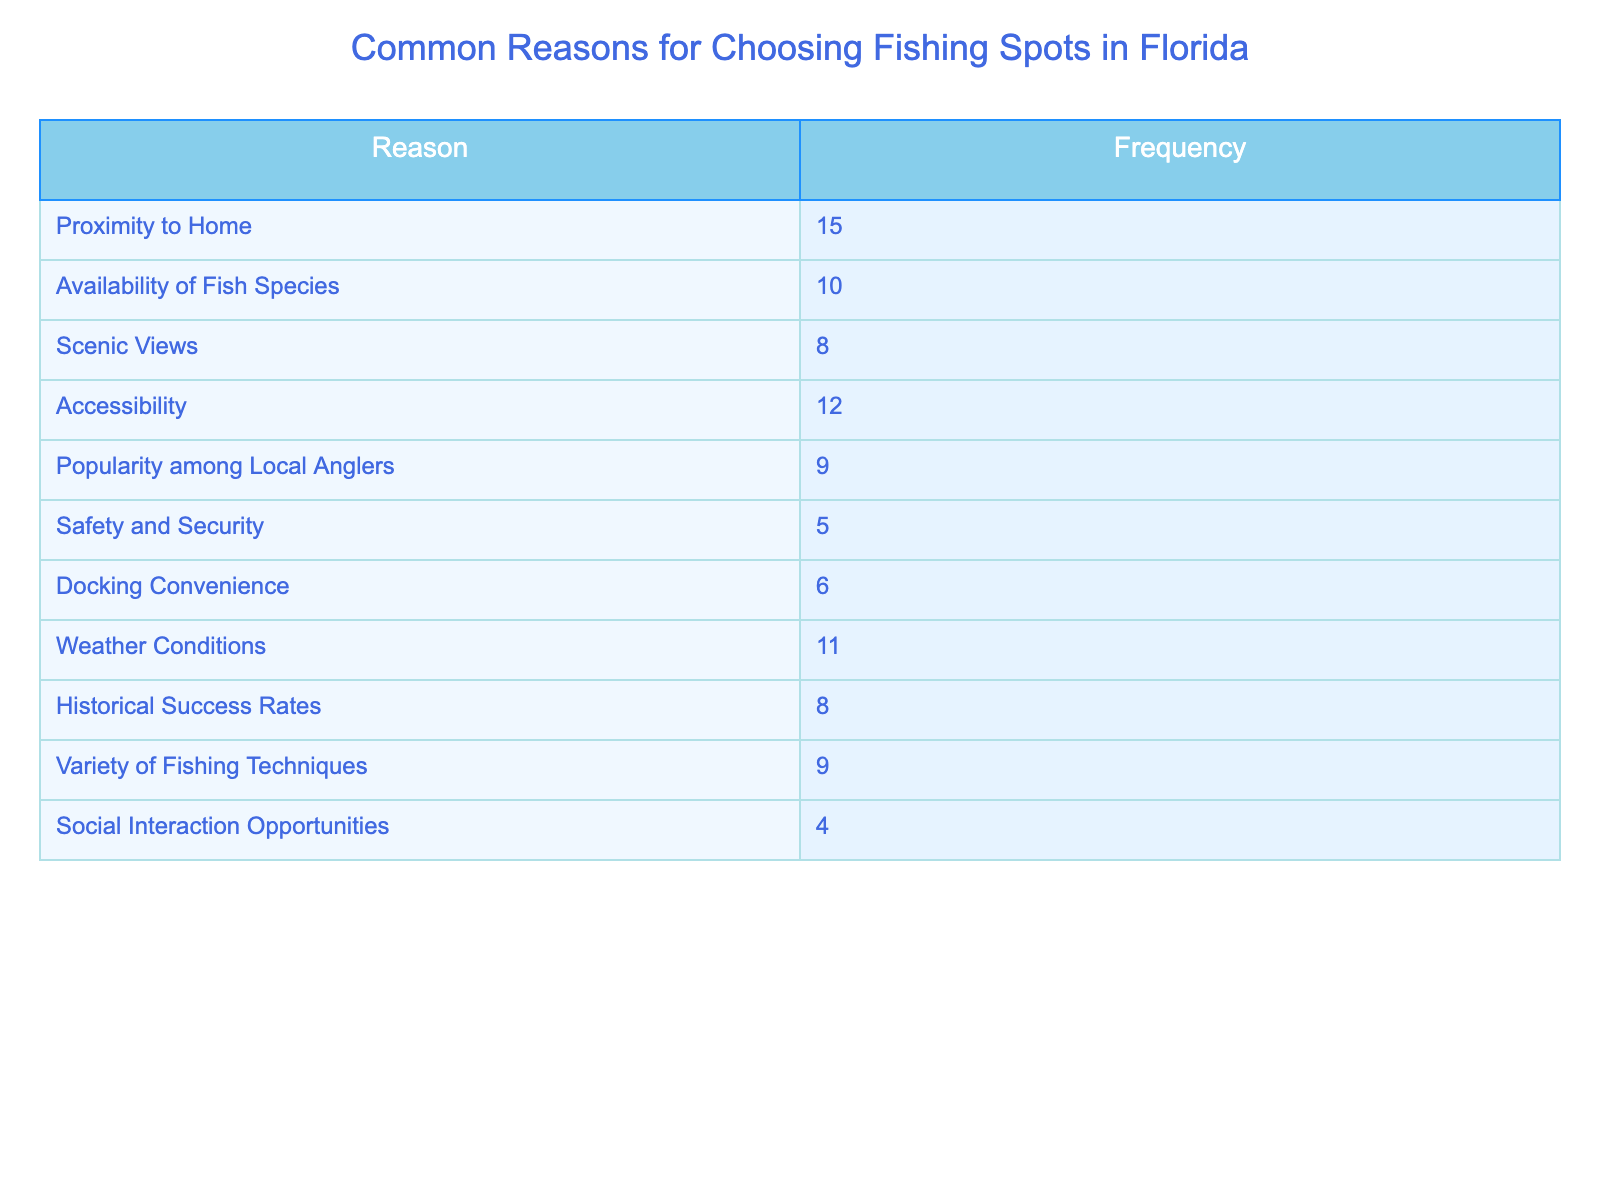What is the most common reason for choosing fishing spots in Florida? The table shows the frequency of each reason for choosing fishing spots in Florida. By looking at the frequency column, "Proximity to Home" has the highest frequency with a value of 15.
Answer: Proximity to Home How many reasons are listed in the table? The table includes a column for reasons and a column for frequency. Counting the reasons listed in the Reasons column, there are a total of 10 reasons.
Answer: 10 Which reason has the lowest frequency? By examining the frequency values in the table, "Social Interaction Opportunities" has the lowest frequency at 4.
Answer: Social Interaction Opportunities What is the average frequency of all reasons listed? To find the average, first sum all the frequencies: (15 + 10 + 8 + 12 + 9 + 5 + 6 + 11 + 8 + 9) = 89. Then, divide by the number of reasons (10): 89 / 10 = 8.9.
Answer: 8.9 Is "Weather Conditions" a more common reason than "Docking Convenience"? Comparing the frequencies from the table, "Weather Conditions" has a frequency of 11, while "Docking Convenience" has a frequency of 6. Since 11 is greater than 6, the answer is yes.
Answer: Yes How many reasons have a frequency of 8 or more? Looking through the frequency values, the reasons with frequencies of 8 or more are: Proximity to Home (15), Weather Conditions (11), Accessibility (12), Variety of Fishing Techniques (9), Availability of Fish Species (10), Scenic Views (8), and Historical Success Rates (8) - a total of 7 reasons.
Answer: 7 What is the difference in frequency between "Proximity to Home" and "Safety and Security"? "Proximity to Home" has a frequency of 15, while "Safety and Security" has a frequency of 5. The difference is calculated as 15 - 5 = 10.
Answer: 10 Which reason, "Popularity among Local Anglers" or "Accessibility," is chosen more frequently? From the table, "Popularity among Local Anglers" has a frequency of 9, and "Accessibility" has a frequency of 12. Since 12 is greater than 9, "Accessibility" is chosen more frequently.
Answer: Accessibility What percentage of the total reasons does "Docking Convenience" represent? First, find the total frequency, which is 89. "Docking Convenience" has a frequency of 6. To find the percentage, divide 6 by 89 and then multiply by 100: (6/89)*100 = 6.74%.
Answer: 6.74% 